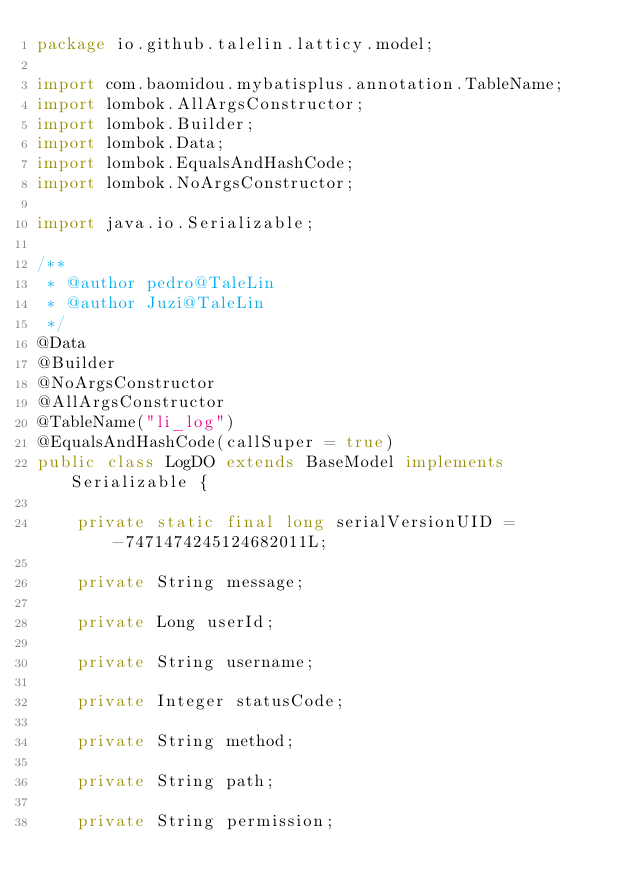<code> <loc_0><loc_0><loc_500><loc_500><_Java_>package io.github.talelin.latticy.model;

import com.baomidou.mybatisplus.annotation.TableName;
import lombok.AllArgsConstructor;
import lombok.Builder;
import lombok.Data;
import lombok.EqualsAndHashCode;
import lombok.NoArgsConstructor;

import java.io.Serializable;

/**
 * @author pedro@TaleLin
 * @author Juzi@TaleLin
 */
@Data
@Builder
@NoArgsConstructor
@AllArgsConstructor
@TableName("li_log")
@EqualsAndHashCode(callSuper = true)
public class LogDO extends BaseModel implements Serializable {

    private static final long serialVersionUID = -7471474245124682011L;

    private String message;

    private Long userId;

    private String username;

    private Integer statusCode;

    private String method;

    private String path;

    private String permission;
</code> 